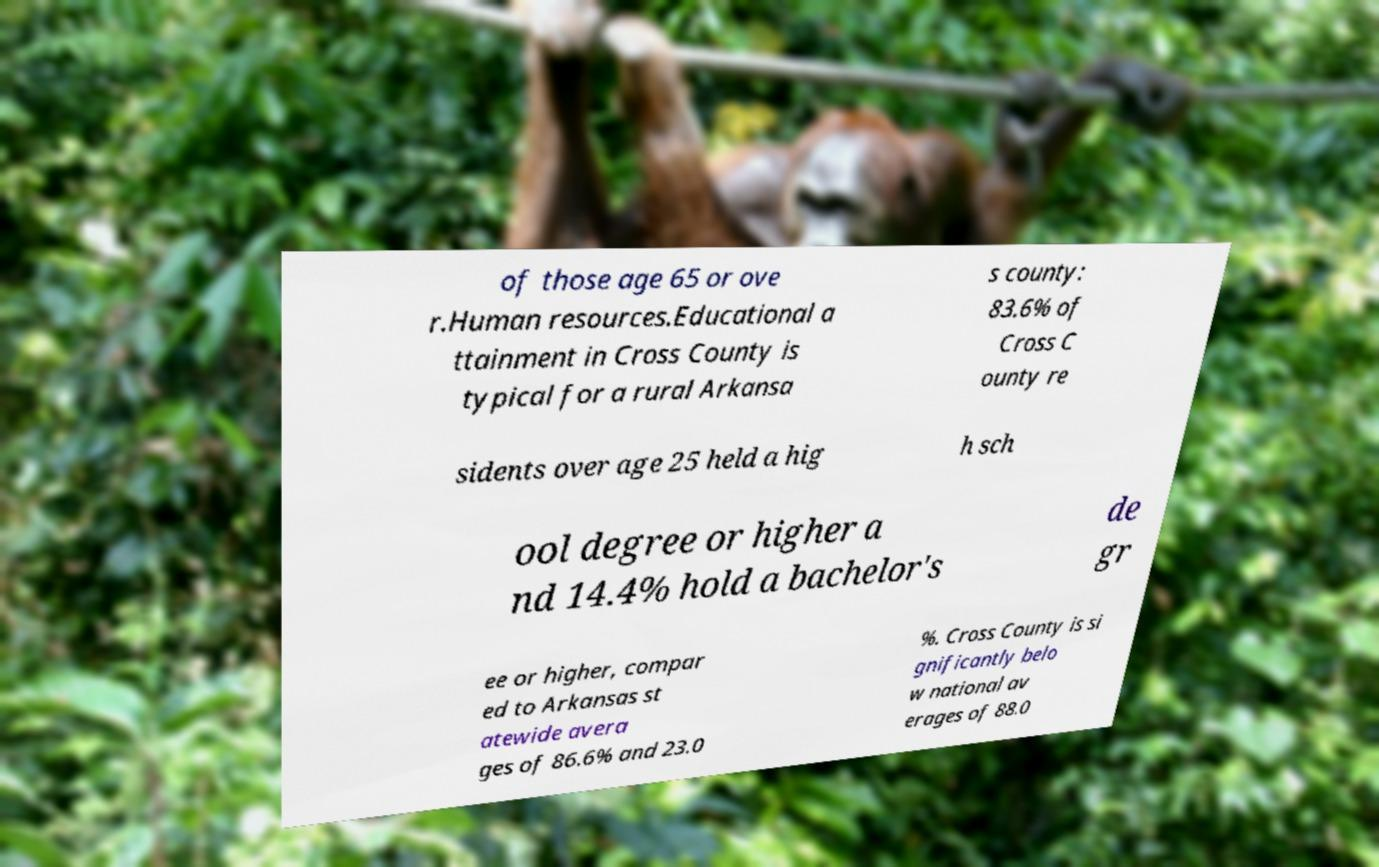For documentation purposes, I need the text within this image transcribed. Could you provide that? of those age 65 or ove r.Human resources.Educational a ttainment in Cross County is typical for a rural Arkansa s county: 83.6% of Cross C ounty re sidents over age 25 held a hig h sch ool degree or higher a nd 14.4% hold a bachelor's de gr ee or higher, compar ed to Arkansas st atewide avera ges of 86.6% and 23.0 %. Cross County is si gnificantly belo w national av erages of 88.0 